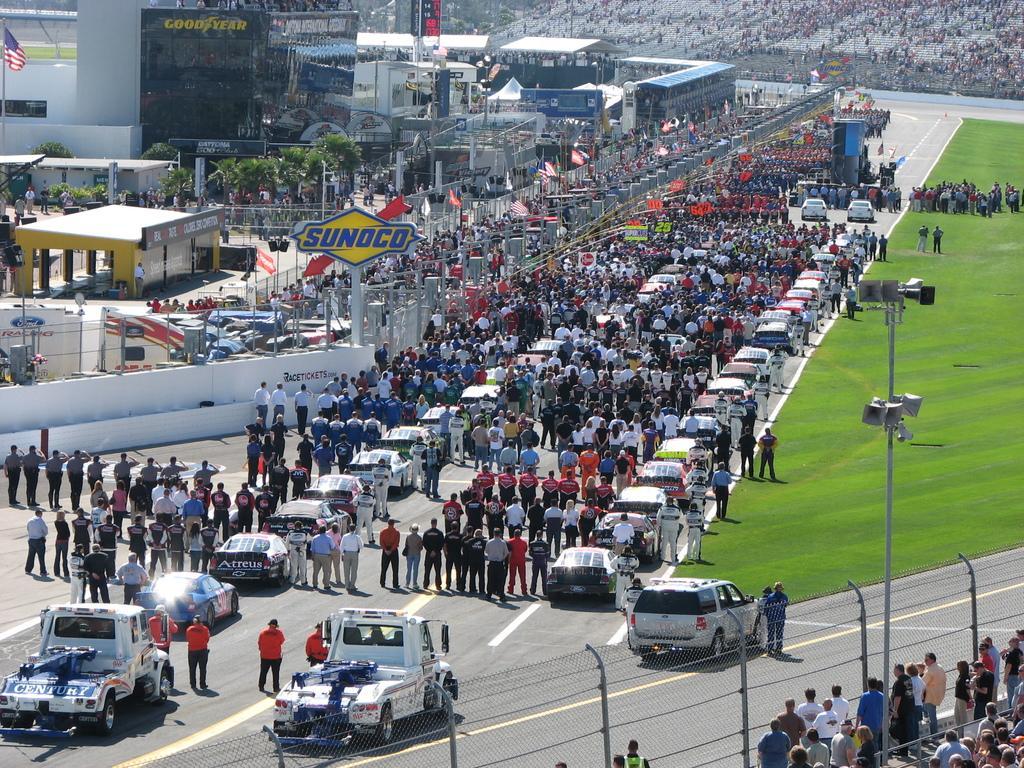How would you summarize this image in a sentence or two? In the center of the image we can see vehicles and crowd on the road. In the background there are buildings and ground. There are sheds, trees and flags. At the bottom there is a fence and we can see a pole. 